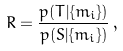<formula> <loc_0><loc_0><loc_500><loc_500>R = \frac { p ( T | \{ m _ { i } \} ) } { p ( S | \{ m _ { i } \} ) } \, ,</formula> 